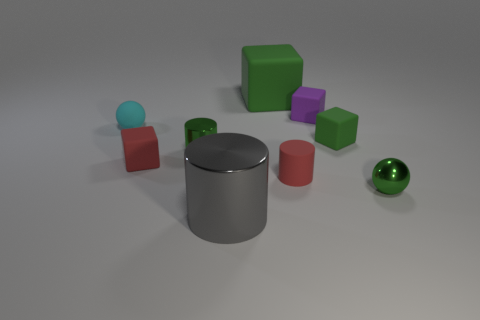Does the big rubber thing have the same color as the sphere on the right side of the tiny green cylinder?
Give a very brief answer. Yes. There is a tiny object that is the same color as the rubber cylinder; what is it made of?
Provide a short and direct response. Rubber. Is the number of green metallic balls behind the purple thing less than the number of small spheres that are right of the tiny green matte thing?
Provide a short and direct response. Yes. What number of things are metallic cylinders that are in front of the small green shiny cylinder or large cyan matte spheres?
Your answer should be very brief. 1. The tiny red matte thing to the left of the tiny red rubber object right of the gray metallic cylinder is what shape?
Your answer should be compact. Cube. Is there a matte block that has the same size as the red cylinder?
Give a very brief answer. Yes. Is the number of large cylinders greater than the number of small brown shiny cylinders?
Give a very brief answer. Yes. Is the size of the matte cube left of the large gray metal object the same as the ball on the right side of the gray cylinder?
Your answer should be compact. Yes. What number of green objects are behind the red rubber cube and on the right side of the large gray metallic cylinder?
Give a very brief answer. 2. There is another big rubber thing that is the same shape as the purple object; what color is it?
Your answer should be very brief. Green. 